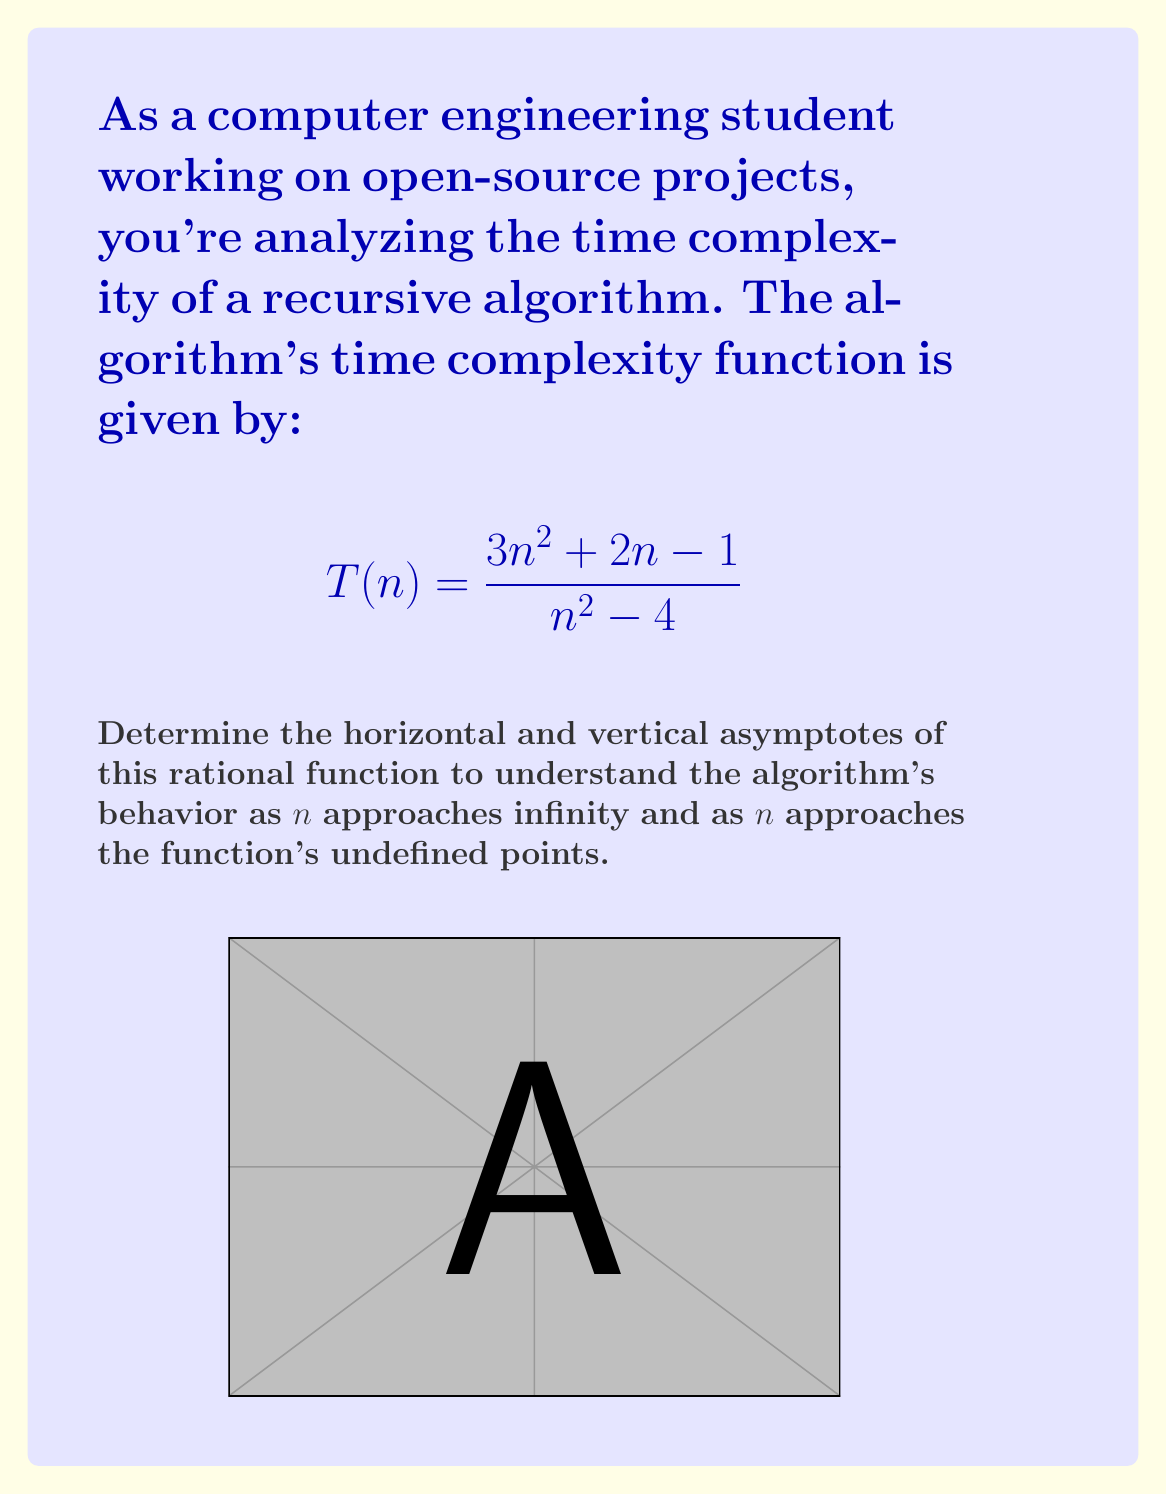Show me your answer to this math problem. To find the asymptotes, we'll follow these steps:

1. Vertical asymptotes:
   Set the denominator to zero and solve for $n$:
   $$n^2 - 4 = 0$$
   $$(n+2)(n-2) = 0$$
   $$n = \pm 2$$
   So, there are vertical asymptotes at $n = 2$ and $n = -2$.

2. Horizontal asymptote:
   Compare the degrees of the numerator and denominator:
   Numerator degree: 2
   Denominator degree: 2
   Since they're equal, divide the leading coefficients:
   $$\lim_{n \to \infty} \frac{3n^2 + 2n - 1}{n^2 - 4} = \frac{3n^2}{n^2} = 3$$
   Therefore, the horizontal asymptote is $y = 3$.

3. To verify, let's examine the behavior as $n$ approaches infinity:
   $$\lim_{n \to \infty} \frac{3n^2 + 2n - 1}{n^2 - 4}$$
   $$= \lim_{n \to \infty} \frac{3 + \frac{2}{n} - \frac{1}{n^2}}{1 - \frac{4}{n^2}}$$
   $$= \frac{3 + 0 - 0}{1 - 0} = 3$$

This analysis shows that as $n$ grows large, the time complexity approaches a constant factor of 3, indicating that the algorithm has $O(1)$ time complexity for very large inputs.
Answer: Vertical asymptotes: $n = \pm 2$; Horizontal asymptote: $y = 3$ 